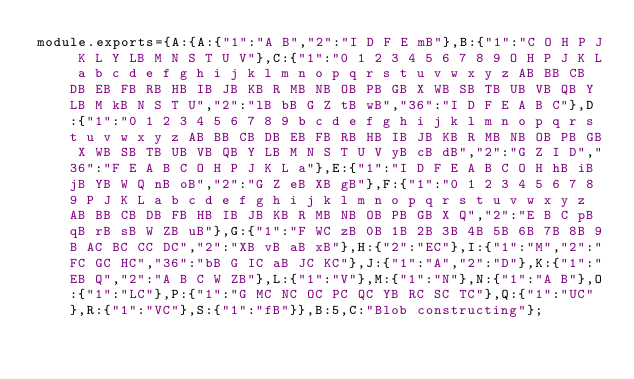Convert code to text. <code><loc_0><loc_0><loc_500><loc_500><_JavaScript_>module.exports={A:{A:{"1":"A B","2":"I D F E mB"},B:{"1":"C O H P J K L Y LB M N S T U V"},C:{"1":"0 1 2 3 4 5 6 7 8 9 O H P J K L a b c d e f g h i j k l m n o p q r s t u v w x y z AB BB CB DB EB FB RB HB IB JB KB R MB NB OB PB GB X WB SB TB UB VB QB Y LB M kB N S T U","2":"lB bB G Z tB wB","36":"I D F E A B C"},D:{"1":"0 1 2 3 4 5 6 7 8 9 b c d e f g h i j k l m n o p q r s t u v w x y z AB BB CB DB EB FB RB HB IB JB KB R MB NB OB PB GB X WB SB TB UB VB QB Y LB M N S T U V yB cB dB","2":"G Z I D","36":"F E A B C O H P J K L a"},E:{"1":"I D F E A B C O H hB iB jB YB W Q nB oB","2":"G Z eB XB gB"},F:{"1":"0 1 2 3 4 5 6 7 8 9 P J K L a b c d e f g h i j k l m n o p q r s t u v w x y z AB BB CB DB FB HB IB JB KB R MB NB OB PB GB X Q","2":"E B C pB qB rB sB W ZB uB"},G:{"1":"F WC zB 0B 1B 2B 3B 4B 5B 6B 7B 8B 9B AC BC CC DC","2":"XB vB aB xB"},H:{"2":"EC"},I:{"1":"M","2":"FC GC HC","36":"bB G IC aB JC KC"},J:{"1":"A","2":"D"},K:{"1":"EB Q","2":"A B C W ZB"},L:{"1":"V"},M:{"1":"N"},N:{"1":"A B"},O:{"1":"LC"},P:{"1":"G MC NC OC PC QC YB RC SC TC"},Q:{"1":"UC"},R:{"1":"VC"},S:{"1":"fB"}},B:5,C:"Blob constructing"};
</code> 